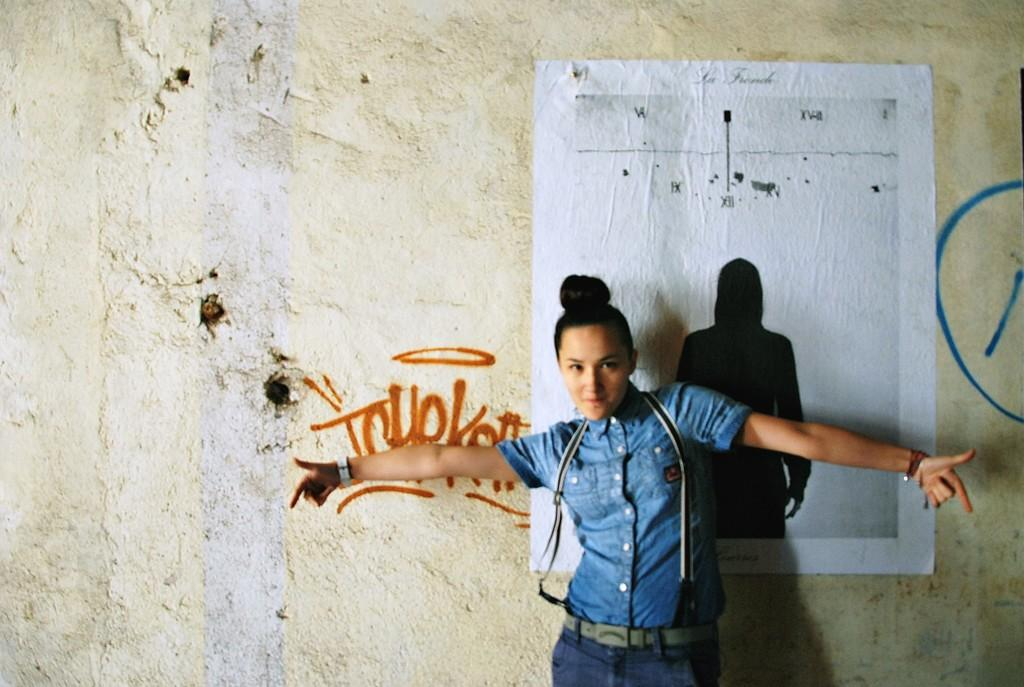What is the main subject of the image? There is a person standing in the image. What is the person wearing that is visible in the image? The person is wearing a bag. What can be seen in the background of the image? There is a wall in the background of the image. What is on the wall in the image? There is a poster on the wall. What is written or depicted on the wall or poster? There is text on the wall or poster. Can you tell me how many times the person kicks the badge in the image? There is no badge present in the image, and therefore no kicking can be observed. What type of humor is depicted in the image? There is no humor depicted in the image; it features a person standing with a bag and a poster on the wall. 